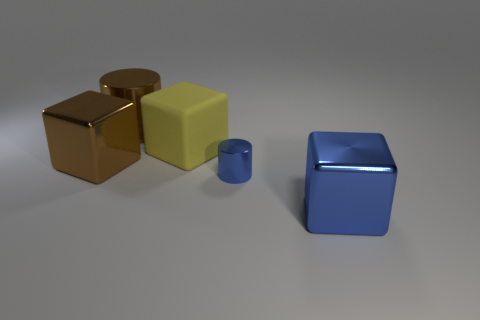Is there any other thing that is the same material as the yellow block?
Give a very brief answer. No. Are there any other things that are the same size as the blue shiny cylinder?
Your answer should be very brief. No. Are there fewer blue cylinders that are left of the tiny blue object than small red rubber balls?
Ensure brevity in your answer.  No. Do the large blue metal object and the yellow matte object have the same shape?
Offer a terse response. Yes. Are there any tiny yellow shiny balls?
Your answer should be very brief. No. There is a big yellow matte thing; is its shape the same as the big metal object to the left of the big cylinder?
Offer a terse response. Yes. What is the material of the large cylinder that is to the left of the large metal cube that is right of the small shiny cylinder?
Your response must be concise. Metal. What color is the tiny metal cylinder?
Give a very brief answer. Blue. There is a cube that is to the left of the big yellow matte cube; is its color the same as the cylinder on the left side of the small blue thing?
Keep it short and to the point. Yes. Are there any tiny cylinders of the same color as the large metallic cylinder?
Your answer should be very brief. No. 